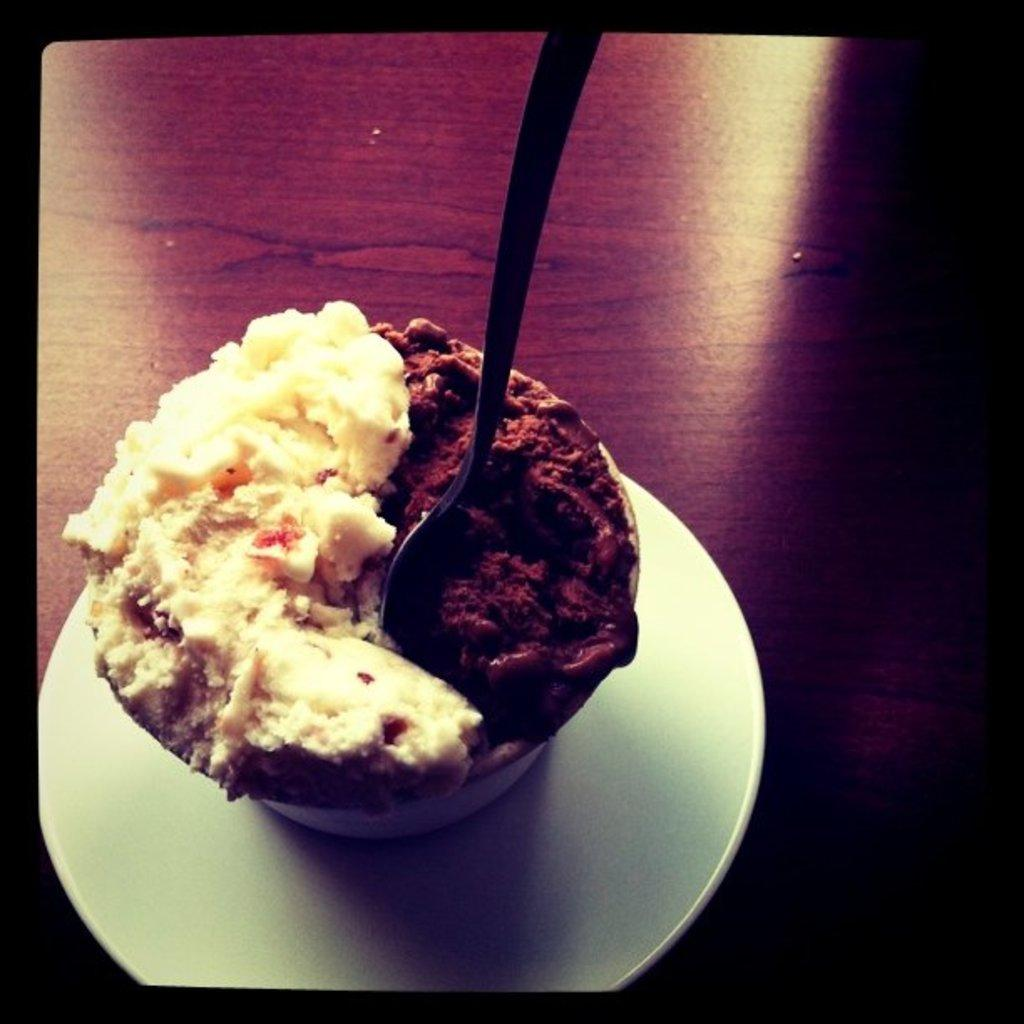What type of dessert is featured in the image? There is ice cream in the image. How is the ice cream contained in the image? The ice cream is in a cup. What colors can be seen in the ice cream? The ice cream has two different colors: brown and cream. What is the cup placed on in the image? The cup is in a plate. What utensil is used for the ice cream in the image? There is a spoon in the ice cream. What type of canvas is used to create the background of the image? There is no canvas present in the image; it is a photograph of ice cream in a cup. Can you see a frog sitting on the spoon in the image? No, there is no frog present in the image. 